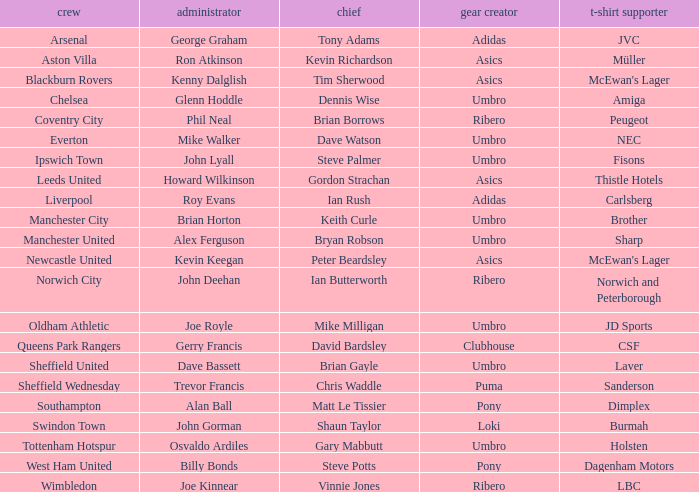What is the kit manufacturer that has billy bonds as the manager? Pony. 